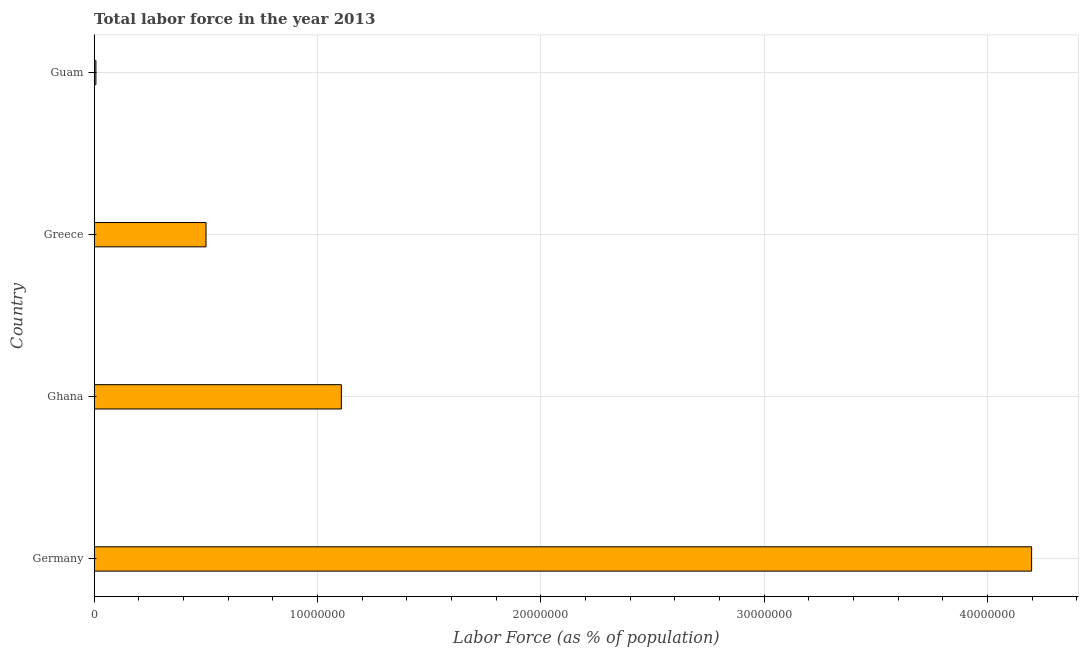Does the graph contain any zero values?
Your answer should be compact. No. Does the graph contain grids?
Give a very brief answer. Yes. What is the title of the graph?
Ensure brevity in your answer.  Total labor force in the year 2013. What is the label or title of the X-axis?
Make the answer very short. Labor Force (as % of population). What is the label or title of the Y-axis?
Keep it short and to the point. Country. What is the total labor force in Greece?
Make the answer very short. 5.01e+06. Across all countries, what is the maximum total labor force?
Provide a short and direct response. 4.20e+07. Across all countries, what is the minimum total labor force?
Keep it short and to the point. 7.62e+04. In which country was the total labor force maximum?
Ensure brevity in your answer.  Germany. In which country was the total labor force minimum?
Keep it short and to the point. Guam. What is the sum of the total labor force?
Give a very brief answer. 5.81e+07. What is the difference between the total labor force in Greece and Guam?
Your response must be concise. 4.93e+06. What is the average total labor force per country?
Your answer should be very brief. 1.45e+07. What is the median total labor force?
Provide a short and direct response. 8.04e+06. What is the ratio of the total labor force in Ghana to that in Guam?
Offer a terse response. 145.17. What is the difference between the highest and the second highest total labor force?
Offer a very short reply. 3.09e+07. What is the difference between the highest and the lowest total labor force?
Keep it short and to the point. 4.19e+07. In how many countries, is the total labor force greater than the average total labor force taken over all countries?
Provide a short and direct response. 1. How many bars are there?
Keep it short and to the point. 4. What is the difference between two consecutive major ticks on the X-axis?
Your answer should be compact. 1.00e+07. Are the values on the major ticks of X-axis written in scientific E-notation?
Your answer should be compact. No. What is the Labor Force (as % of population) in Germany?
Offer a terse response. 4.20e+07. What is the Labor Force (as % of population) in Ghana?
Keep it short and to the point. 1.11e+07. What is the Labor Force (as % of population) in Greece?
Your answer should be very brief. 5.01e+06. What is the Labor Force (as % of population) of Guam?
Your response must be concise. 7.62e+04. What is the difference between the Labor Force (as % of population) in Germany and Ghana?
Offer a very short reply. 3.09e+07. What is the difference between the Labor Force (as % of population) in Germany and Greece?
Provide a short and direct response. 3.70e+07. What is the difference between the Labor Force (as % of population) in Germany and Guam?
Your answer should be compact. 4.19e+07. What is the difference between the Labor Force (as % of population) in Ghana and Greece?
Offer a very short reply. 6.06e+06. What is the difference between the Labor Force (as % of population) in Ghana and Guam?
Offer a terse response. 1.10e+07. What is the difference between the Labor Force (as % of population) in Greece and Guam?
Your answer should be compact. 4.93e+06. What is the ratio of the Labor Force (as % of population) in Germany to that in Ghana?
Offer a terse response. 3.79. What is the ratio of the Labor Force (as % of population) in Germany to that in Greece?
Keep it short and to the point. 8.38. What is the ratio of the Labor Force (as % of population) in Germany to that in Guam?
Provide a succinct answer. 550.58. What is the ratio of the Labor Force (as % of population) in Ghana to that in Greece?
Provide a short and direct response. 2.21. What is the ratio of the Labor Force (as % of population) in Ghana to that in Guam?
Offer a very short reply. 145.17. What is the ratio of the Labor Force (as % of population) in Greece to that in Guam?
Offer a terse response. 65.68. 